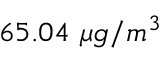<formula> <loc_0><loc_0><loc_500><loc_500>6 5 . 0 4 \ \mu g / m ^ { 3 }</formula> 